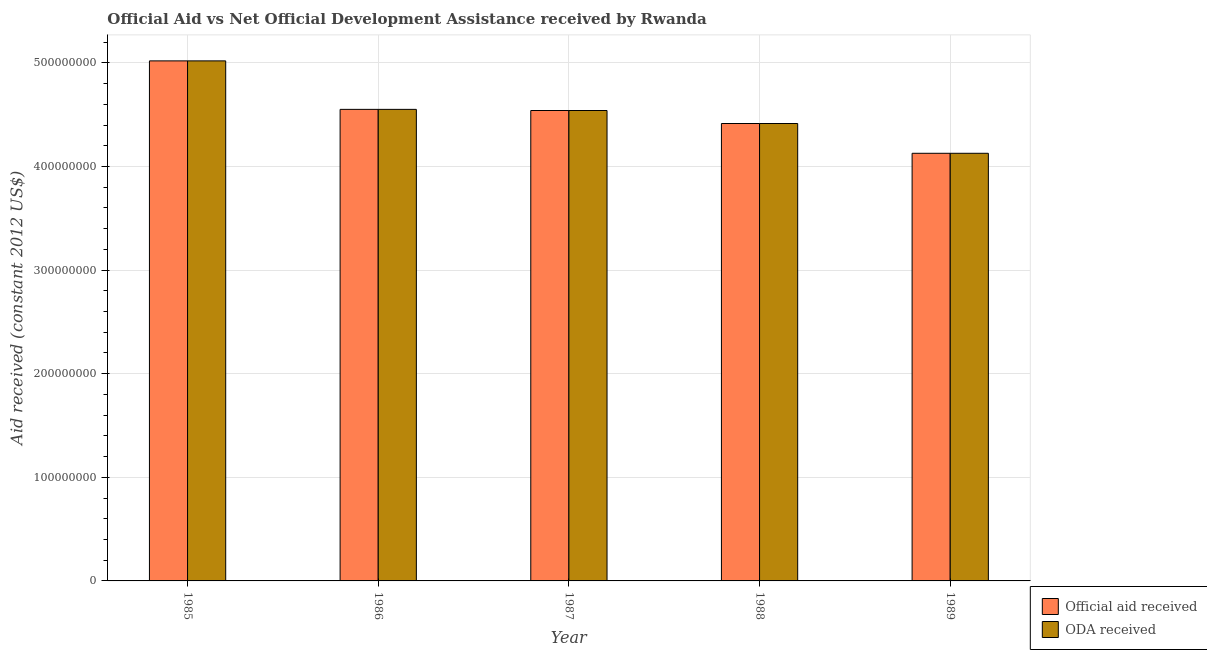How many different coloured bars are there?
Make the answer very short. 2. Are the number of bars on each tick of the X-axis equal?
Provide a short and direct response. Yes. How many bars are there on the 3rd tick from the right?
Your answer should be very brief. 2. What is the official aid received in 1987?
Keep it short and to the point. 4.54e+08. Across all years, what is the maximum oda received?
Provide a short and direct response. 5.02e+08. Across all years, what is the minimum official aid received?
Provide a succinct answer. 4.13e+08. In which year was the oda received minimum?
Your answer should be compact. 1989. What is the total official aid received in the graph?
Ensure brevity in your answer.  2.27e+09. What is the difference between the oda received in 1987 and that in 1989?
Provide a short and direct response. 4.13e+07. What is the difference between the oda received in 1985 and the official aid received in 1986?
Your answer should be compact. 4.68e+07. What is the average official aid received per year?
Give a very brief answer. 4.53e+08. In how many years, is the oda received greater than 280000000 US$?
Your answer should be compact. 5. What is the ratio of the oda received in 1987 to that in 1988?
Offer a very short reply. 1.03. What is the difference between the highest and the second highest official aid received?
Make the answer very short. 4.68e+07. What is the difference between the highest and the lowest oda received?
Give a very brief answer. 8.92e+07. In how many years, is the oda received greater than the average oda received taken over all years?
Keep it short and to the point. 3. Is the sum of the official aid received in 1985 and 1989 greater than the maximum oda received across all years?
Ensure brevity in your answer.  Yes. What does the 1st bar from the left in 1986 represents?
Your answer should be compact. Official aid received. What does the 2nd bar from the right in 1988 represents?
Ensure brevity in your answer.  Official aid received. How many bars are there?
Provide a succinct answer. 10. Are the values on the major ticks of Y-axis written in scientific E-notation?
Provide a succinct answer. No. Does the graph contain any zero values?
Make the answer very short. No. How many legend labels are there?
Offer a terse response. 2. What is the title of the graph?
Make the answer very short. Official Aid vs Net Official Development Assistance received by Rwanda . What is the label or title of the Y-axis?
Your response must be concise. Aid received (constant 2012 US$). What is the Aid received (constant 2012 US$) in Official aid received in 1985?
Your response must be concise. 5.02e+08. What is the Aid received (constant 2012 US$) in ODA received in 1985?
Offer a terse response. 5.02e+08. What is the Aid received (constant 2012 US$) of Official aid received in 1986?
Your response must be concise. 4.55e+08. What is the Aid received (constant 2012 US$) of ODA received in 1986?
Keep it short and to the point. 4.55e+08. What is the Aid received (constant 2012 US$) of Official aid received in 1987?
Ensure brevity in your answer.  4.54e+08. What is the Aid received (constant 2012 US$) of ODA received in 1987?
Give a very brief answer. 4.54e+08. What is the Aid received (constant 2012 US$) in Official aid received in 1988?
Keep it short and to the point. 4.41e+08. What is the Aid received (constant 2012 US$) in ODA received in 1988?
Ensure brevity in your answer.  4.41e+08. What is the Aid received (constant 2012 US$) of Official aid received in 1989?
Offer a very short reply. 4.13e+08. What is the Aid received (constant 2012 US$) in ODA received in 1989?
Provide a succinct answer. 4.13e+08. Across all years, what is the maximum Aid received (constant 2012 US$) in Official aid received?
Offer a terse response. 5.02e+08. Across all years, what is the maximum Aid received (constant 2012 US$) in ODA received?
Your answer should be very brief. 5.02e+08. Across all years, what is the minimum Aid received (constant 2012 US$) of Official aid received?
Give a very brief answer. 4.13e+08. Across all years, what is the minimum Aid received (constant 2012 US$) in ODA received?
Ensure brevity in your answer.  4.13e+08. What is the total Aid received (constant 2012 US$) of Official aid received in the graph?
Make the answer very short. 2.27e+09. What is the total Aid received (constant 2012 US$) in ODA received in the graph?
Your answer should be compact. 2.27e+09. What is the difference between the Aid received (constant 2012 US$) of Official aid received in 1985 and that in 1986?
Provide a short and direct response. 4.68e+07. What is the difference between the Aid received (constant 2012 US$) of ODA received in 1985 and that in 1986?
Your answer should be compact. 4.68e+07. What is the difference between the Aid received (constant 2012 US$) in Official aid received in 1985 and that in 1987?
Your answer should be very brief. 4.79e+07. What is the difference between the Aid received (constant 2012 US$) in ODA received in 1985 and that in 1987?
Ensure brevity in your answer.  4.79e+07. What is the difference between the Aid received (constant 2012 US$) of Official aid received in 1985 and that in 1988?
Make the answer very short. 6.04e+07. What is the difference between the Aid received (constant 2012 US$) of ODA received in 1985 and that in 1988?
Your answer should be very brief. 6.04e+07. What is the difference between the Aid received (constant 2012 US$) of Official aid received in 1985 and that in 1989?
Your answer should be very brief. 8.92e+07. What is the difference between the Aid received (constant 2012 US$) in ODA received in 1985 and that in 1989?
Provide a short and direct response. 8.92e+07. What is the difference between the Aid received (constant 2012 US$) in Official aid received in 1986 and that in 1987?
Make the answer very short. 1.11e+06. What is the difference between the Aid received (constant 2012 US$) of ODA received in 1986 and that in 1987?
Give a very brief answer. 1.11e+06. What is the difference between the Aid received (constant 2012 US$) of Official aid received in 1986 and that in 1988?
Make the answer very short. 1.36e+07. What is the difference between the Aid received (constant 2012 US$) of ODA received in 1986 and that in 1988?
Provide a short and direct response. 1.36e+07. What is the difference between the Aid received (constant 2012 US$) of Official aid received in 1986 and that in 1989?
Keep it short and to the point. 4.24e+07. What is the difference between the Aid received (constant 2012 US$) in ODA received in 1986 and that in 1989?
Your answer should be very brief. 4.24e+07. What is the difference between the Aid received (constant 2012 US$) in Official aid received in 1987 and that in 1988?
Provide a short and direct response. 1.25e+07. What is the difference between the Aid received (constant 2012 US$) of ODA received in 1987 and that in 1988?
Provide a short and direct response. 1.25e+07. What is the difference between the Aid received (constant 2012 US$) of Official aid received in 1987 and that in 1989?
Your answer should be compact. 4.13e+07. What is the difference between the Aid received (constant 2012 US$) in ODA received in 1987 and that in 1989?
Give a very brief answer. 4.13e+07. What is the difference between the Aid received (constant 2012 US$) in Official aid received in 1988 and that in 1989?
Offer a very short reply. 2.88e+07. What is the difference between the Aid received (constant 2012 US$) of ODA received in 1988 and that in 1989?
Provide a succinct answer. 2.88e+07. What is the difference between the Aid received (constant 2012 US$) of Official aid received in 1985 and the Aid received (constant 2012 US$) of ODA received in 1986?
Keep it short and to the point. 4.68e+07. What is the difference between the Aid received (constant 2012 US$) of Official aid received in 1985 and the Aid received (constant 2012 US$) of ODA received in 1987?
Give a very brief answer. 4.79e+07. What is the difference between the Aid received (constant 2012 US$) of Official aid received in 1985 and the Aid received (constant 2012 US$) of ODA received in 1988?
Offer a very short reply. 6.04e+07. What is the difference between the Aid received (constant 2012 US$) in Official aid received in 1985 and the Aid received (constant 2012 US$) in ODA received in 1989?
Make the answer very short. 8.92e+07. What is the difference between the Aid received (constant 2012 US$) in Official aid received in 1986 and the Aid received (constant 2012 US$) in ODA received in 1987?
Offer a very short reply. 1.11e+06. What is the difference between the Aid received (constant 2012 US$) in Official aid received in 1986 and the Aid received (constant 2012 US$) in ODA received in 1988?
Offer a very short reply. 1.36e+07. What is the difference between the Aid received (constant 2012 US$) in Official aid received in 1986 and the Aid received (constant 2012 US$) in ODA received in 1989?
Provide a short and direct response. 4.24e+07. What is the difference between the Aid received (constant 2012 US$) in Official aid received in 1987 and the Aid received (constant 2012 US$) in ODA received in 1988?
Make the answer very short. 1.25e+07. What is the difference between the Aid received (constant 2012 US$) of Official aid received in 1987 and the Aid received (constant 2012 US$) of ODA received in 1989?
Ensure brevity in your answer.  4.13e+07. What is the difference between the Aid received (constant 2012 US$) in Official aid received in 1988 and the Aid received (constant 2012 US$) in ODA received in 1989?
Keep it short and to the point. 2.88e+07. What is the average Aid received (constant 2012 US$) in Official aid received per year?
Make the answer very short. 4.53e+08. What is the average Aid received (constant 2012 US$) of ODA received per year?
Your response must be concise. 4.53e+08. In the year 1988, what is the difference between the Aid received (constant 2012 US$) in Official aid received and Aid received (constant 2012 US$) in ODA received?
Offer a very short reply. 0. In the year 1989, what is the difference between the Aid received (constant 2012 US$) in Official aid received and Aid received (constant 2012 US$) in ODA received?
Give a very brief answer. 0. What is the ratio of the Aid received (constant 2012 US$) of Official aid received in 1985 to that in 1986?
Offer a very short reply. 1.1. What is the ratio of the Aid received (constant 2012 US$) in ODA received in 1985 to that in 1986?
Offer a very short reply. 1.1. What is the ratio of the Aid received (constant 2012 US$) of Official aid received in 1985 to that in 1987?
Make the answer very short. 1.11. What is the ratio of the Aid received (constant 2012 US$) of ODA received in 1985 to that in 1987?
Give a very brief answer. 1.11. What is the ratio of the Aid received (constant 2012 US$) in Official aid received in 1985 to that in 1988?
Keep it short and to the point. 1.14. What is the ratio of the Aid received (constant 2012 US$) in ODA received in 1985 to that in 1988?
Provide a short and direct response. 1.14. What is the ratio of the Aid received (constant 2012 US$) of Official aid received in 1985 to that in 1989?
Provide a succinct answer. 1.22. What is the ratio of the Aid received (constant 2012 US$) in ODA received in 1985 to that in 1989?
Make the answer very short. 1.22. What is the ratio of the Aid received (constant 2012 US$) of ODA received in 1986 to that in 1987?
Offer a very short reply. 1. What is the ratio of the Aid received (constant 2012 US$) of Official aid received in 1986 to that in 1988?
Offer a terse response. 1.03. What is the ratio of the Aid received (constant 2012 US$) in ODA received in 1986 to that in 1988?
Keep it short and to the point. 1.03. What is the ratio of the Aid received (constant 2012 US$) in Official aid received in 1986 to that in 1989?
Give a very brief answer. 1.1. What is the ratio of the Aid received (constant 2012 US$) in ODA received in 1986 to that in 1989?
Offer a very short reply. 1.1. What is the ratio of the Aid received (constant 2012 US$) in Official aid received in 1987 to that in 1988?
Provide a succinct answer. 1.03. What is the ratio of the Aid received (constant 2012 US$) in ODA received in 1987 to that in 1988?
Offer a very short reply. 1.03. What is the ratio of the Aid received (constant 2012 US$) of ODA received in 1987 to that in 1989?
Ensure brevity in your answer.  1.1. What is the ratio of the Aid received (constant 2012 US$) of Official aid received in 1988 to that in 1989?
Keep it short and to the point. 1.07. What is the ratio of the Aid received (constant 2012 US$) of ODA received in 1988 to that in 1989?
Give a very brief answer. 1.07. What is the difference between the highest and the second highest Aid received (constant 2012 US$) in Official aid received?
Provide a succinct answer. 4.68e+07. What is the difference between the highest and the second highest Aid received (constant 2012 US$) in ODA received?
Keep it short and to the point. 4.68e+07. What is the difference between the highest and the lowest Aid received (constant 2012 US$) of Official aid received?
Your answer should be compact. 8.92e+07. What is the difference between the highest and the lowest Aid received (constant 2012 US$) in ODA received?
Provide a succinct answer. 8.92e+07. 